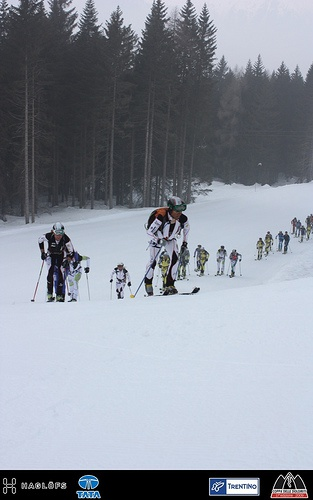Describe the objects in this image and their specific colors. I can see people in lavender, black, darkgray, and gray tones, people in lavender, black, gray, darkgray, and navy tones, people in lavender, lightgray, gray, and darkgray tones, people in lavender, black, darkgray, and gray tones, and people in lavender, darkgray, gray, and black tones in this image. 